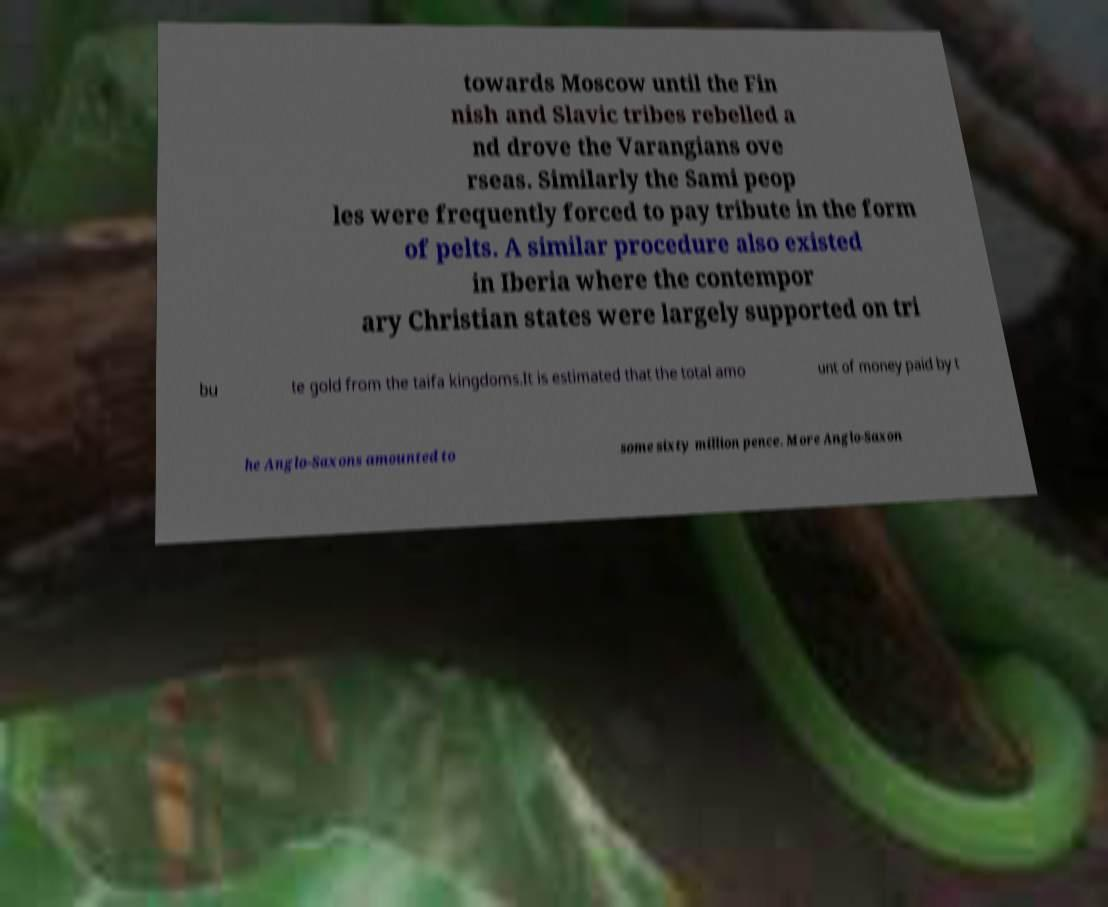There's text embedded in this image that I need extracted. Can you transcribe it verbatim? towards Moscow until the Fin nish and Slavic tribes rebelled a nd drove the Varangians ove rseas. Similarly the Sami peop les were frequently forced to pay tribute in the form of pelts. A similar procedure also existed in Iberia where the contempor ary Christian states were largely supported on tri bu te gold from the taifa kingdoms.It is estimated that the total amo unt of money paid by t he Anglo-Saxons amounted to some sixty million pence. More Anglo-Saxon 